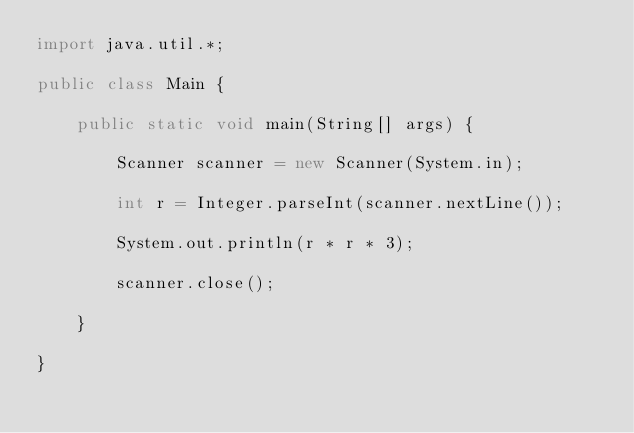<code> <loc_0><loc_0><loc_500><loc_500><_Java_>import java.util.*;

public class Main {

    public static void main(String[] args) {

        Scanner scanner = new Scanner(System.in);

        int r = Integer.parseInt(scanner.nextLine());

        System.out.println(r * r * 3);

        scanner.close();

    }

}</code> 